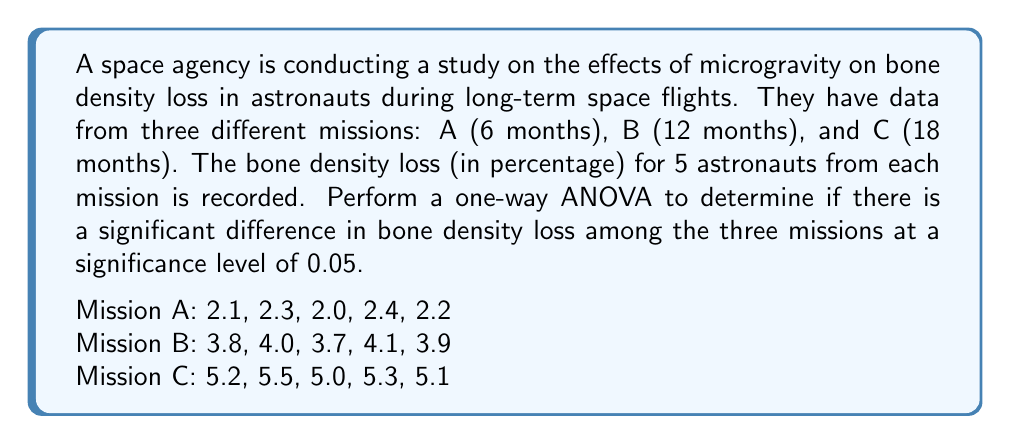Solve this math problem. To perform a one-way ANOVA, we need to follow these steps:

1. Calculate the sum of squares between groups (SSB), sum of squares within groups (SSW), and total sum of squares (SST).
2. Calculate the degrees of freedom for between groups (dfB) and within groups (dfW).
3. Calculate the mean square between groups (MSB) and mean square within groups (MSW).
4. Calculate the F-statistic.
5. Compare the F-statistic with the critical F-value.

Step 1: Calculate SSB, SSW, and SST

First, we need to calculate the grand mean:
$$\bar{X} = \frac{2.1 + 2.3 + ... + 5.3 + 5.1}{15} = 3.64$$

Now, we calculate SSB:
$$SSB = 5[(2.2 - 3.64)^2 + (3.9 - 3.64)^2 + (5.22 - 3.64)^2] = 28.413$$

For SSW, we calculate the sum of squared deviations within each group:
$$SSW_A = (2.1 - 2.2)^2 + (2.3 - 2.2)^2 + (2.0 - 2.2)^2 + (2.4 - 2.2)^2 + (2.2 - 2.2)^2 = 0.1$$
$$SSW_B = (3.8 - 3.9)^2 + (4.0 - 3.9)^2 + (3.7 - 3.9)^2 + (4.1 - 3.9)^2 + (3.9 - 3.9)^2 = 0.1$$
$$SSW_C = (5.2 - 5.22)^2 + (5.5 - 5.22)^2 + (5.0 - 5.22)^2 + (5.3 - 5.22)^2 + (5.1 - 5.22)^2 = 0.137$$

$$SSW = SSW_A + SSW_B + SSW_C = 0.1 + 0.1 + 0.137 = 0.337$$

$$SST = SSB + SSW = 28.413 + 0.337 = 28.75$$

Step 2: Calculate degrees of freedom

$$dfB = k - 1 = 3 - 1 = 2$$ (where k is the number of groups)
$$dfW = N - k = 15 - 3 = 12$$ (where N is the total number of observations)

Step 3: Calculate MSB and MSW

$$MSB = \frac{SSB}{dfB} = \frac{28.413}{2} = 14.2065$$
$$MSW = \frac{SSW}{dfW} = \frac{0.337}{12} = 0.028083$$

Step 4: Calculate F-statistic

$$F = \frac{MSB}{MSW} = \frac{14.2065}{0.028083} = 505.87$$

Step 5: Compare F-statistic with critical F-value

The critical F-value for $\alpha = 0.05$, $dfB = 2$, and $dfW = 12$ is approximately 3.89.

Since our calculated F-statistic (505.87) is much larger than the critical F-value (3.89), we reject the null hypothesis.
Answer: The one-way ANOVA results show a significant difference in bone density loss among the three missions (F(2,12) = 505.87, p < 0.05). We reject the null hypothesis and conclude that the duration of space flight has a significant effect on bone density loss. 